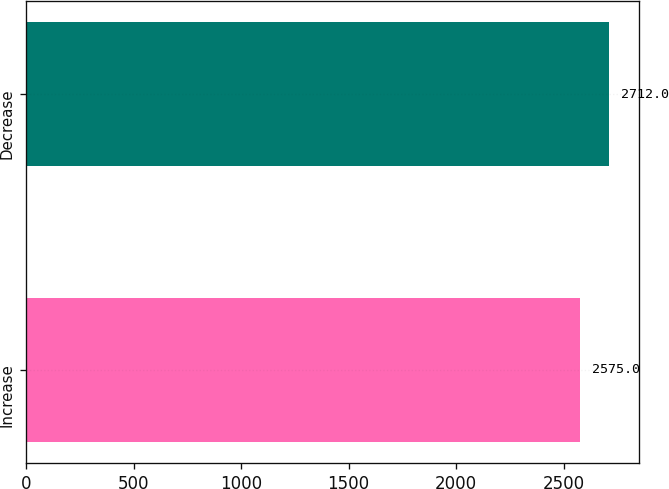Convert chart. <chart><loc_0><loc_0><loc_500><loc_500><bar_chart><fcel>Increase<fcel>Decrease<nl><fcel>2575<fcel>2712<nl></chart> 